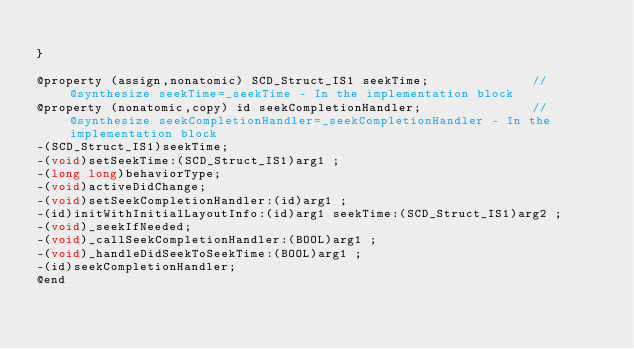Convert code to text. <code><loc_0><loc_0><loc_500><loc_500><_C_>
}

@property (assign,nonatomic) SCD_Struct_IS1 seekTime;              //@synthesize seekTime=_seekTime - In the implementation block
@property (nonatomic,copy) id seekCompletionHandler;               //@synthesize seekCompletionHandler=_seekCompletionHandler - In the implementation block
-(SCD_Struct_IS1)seekTime;
-(void)setSeekTime:(SCD_Struct_IS1)arg1 ;
-(long long)behaviorType;
-(void)activeDidChange;
-(void)setSeekCompletionHandler:(id)arg1 ;
-(id)initWithInitialLayoutInfo:(id)arg1 seekTime:(SCD_Struct_IS1)arg2 ;
-(void)_seekIfNeeded;
-(void)_callSeekCompletionHandler:(BOOL)arg1 ;
-(void)_handleDidSeekToSeekTime:(BOOL)arg1 ;
-(id)seekCompletionHandler;
@end

</code> 